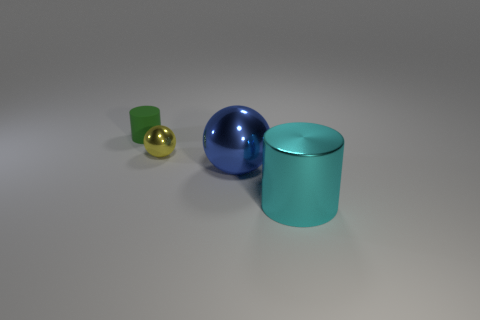The cylinder that is on the left side of the cylinder that is in front of the rubber object is what color?
Your answer should be very brief. Green. Does the green cylinder have the same size as the blue metal thing?
Keep it short and to the point. No. Does the cylinder that is right of the small green cylinder have the same material as the ball on the left side of the large metallic sphere?
Make the answer very short. Yes. What shape is the object that is to the right of the big thing behind the cylinder in front of the yellow object?
Offer a very short reply. Cylinder. Are there more matte cylinders than green balls?
Make the answer very short. Yes. Is there a tiny ball?
Keep it short and to the point. Yes. How many things are either large things behind the large cylinder or objects behind the big ball?
Offer a very short reply. 3. Is the color of the small metallic sphere the same as the matte cylinder?
Provide a short and direct response. No. Are there fewer small matte blocks than cyan metal cylinders?
Keep it short and to the point. Yes. There is a green rubber thing; are there any cyan shiny objects left of it?
Offer a terse response. No. 